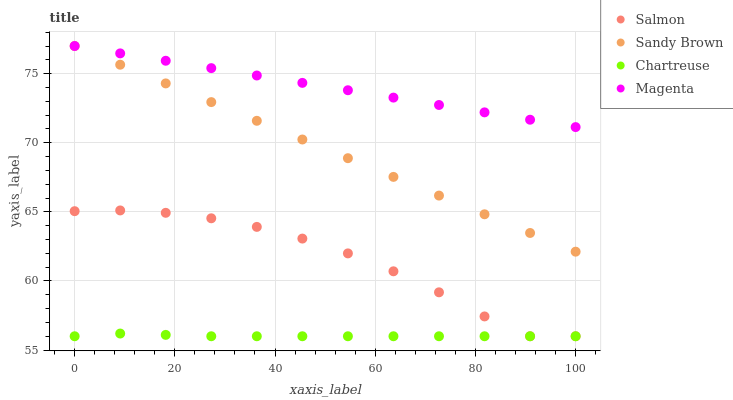Does Chartreuse have the minimum area under the curve?
Answer yes or no. Yes. Does Magenta have the maximum area under the curve?
Answer yes or no. Yes. Does Salmon have the minimum area under the curve?
Answer yes or no. No. Does Salmon have the maximum area under the curve?
Answer yes or no. No. Is Sandy Brown the smoothest?
Answer yes or no. Yes. Is Salmon the roughest?
Answer yes or no. Yes. Is Chartreuse the smoothest?
Answer yes or no. No. Is Chartreuse the roughest?
Answer yes or no. No. Does Chartreuse have the lowest value?
Answer yes or no. Yes. Does Magenta have the lowest value?
Answer yes or no. No. Does Magenta have the highest value?
Answer yes or no. Yes. Does Salmon have the highest value?
Answer yes or no. No. Is Salmon less than Sandy Brown?
Answer yes or no. Yes. Is Magenta greater than Salmon?
Answer yes or no. Yes. Does Sandy Brown intersect Magenta?
Answer yes or no. Yes. Is Sandy Brown less than Magenta?
Answer yes or no. No. Is Sandy Brown greater than Magenta?
Answer yes or no. No. Does Salmon intersect Sandy Brown?
Answer yes or no. No. 